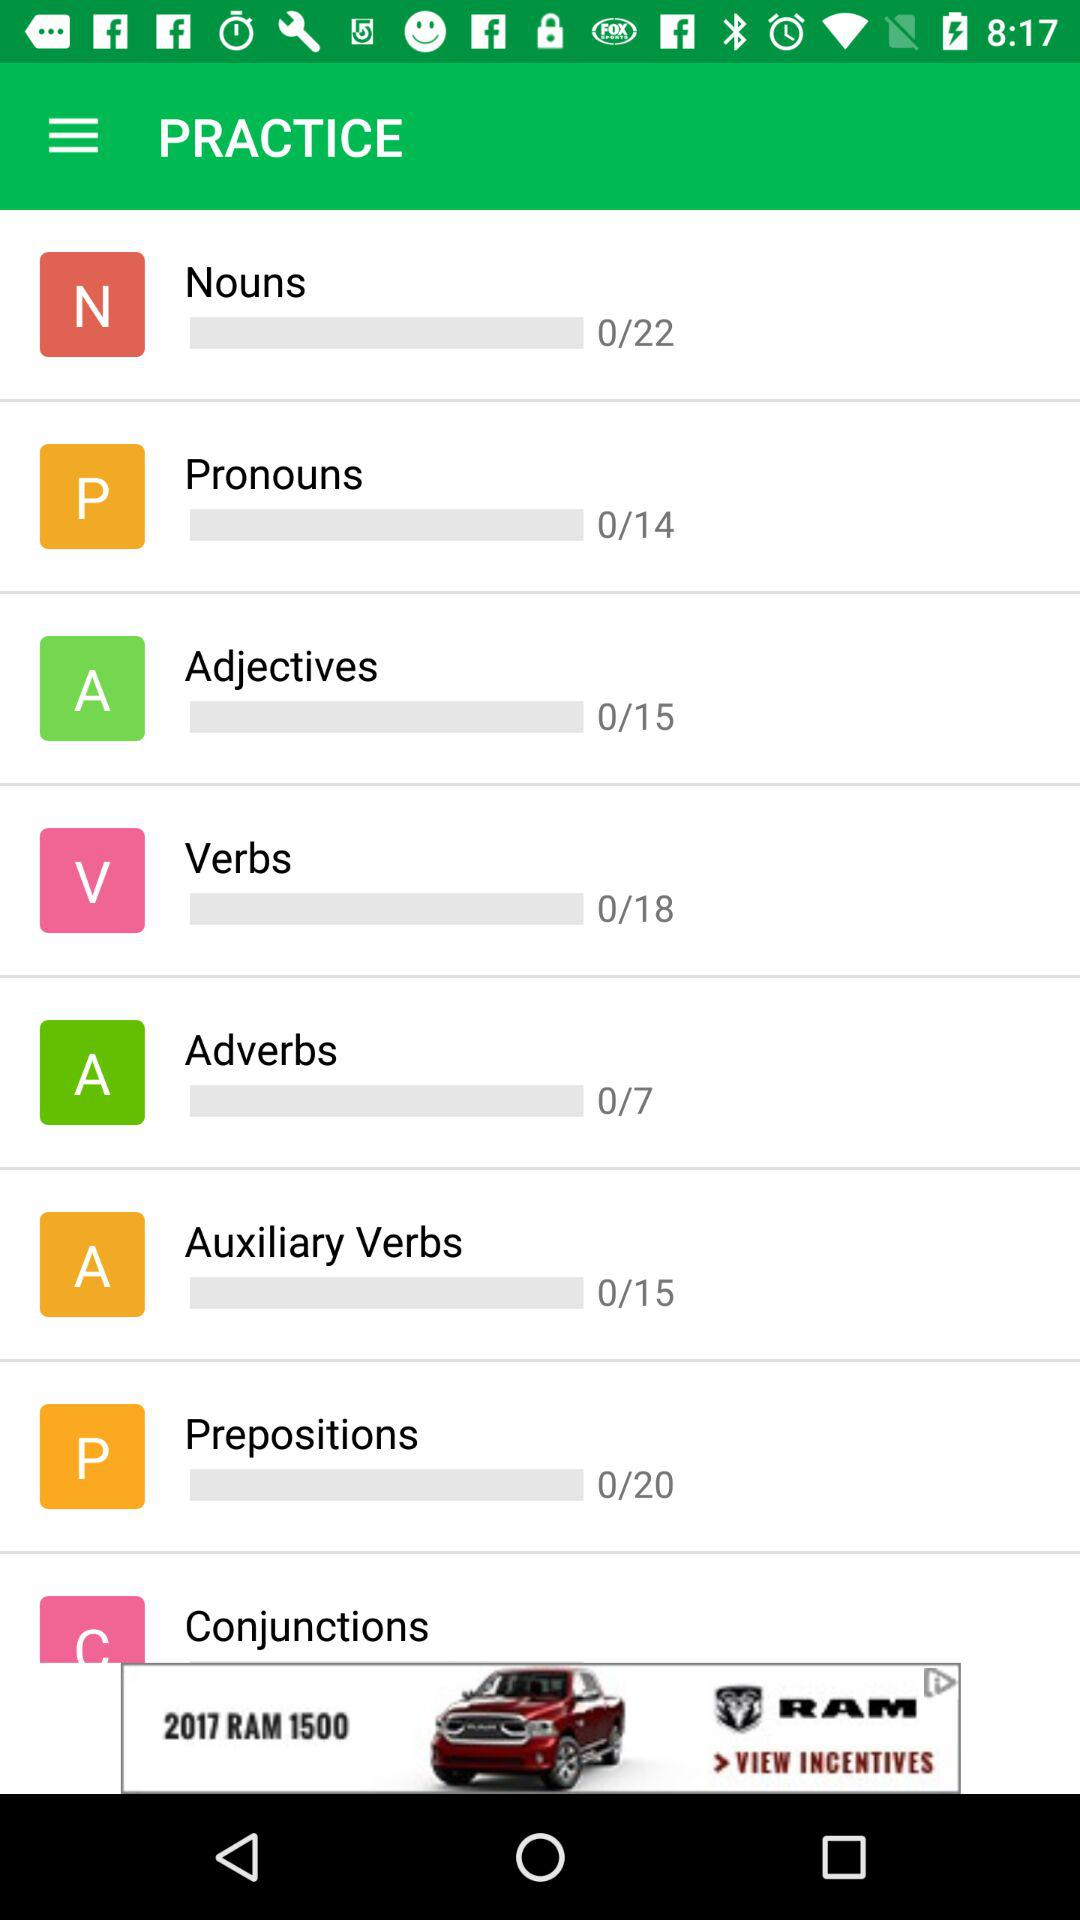How many practice tests of verbs have been completed? There are 0 practice tests of verbs that have been completed. 